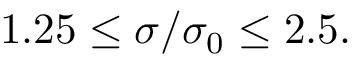<formula> <loc_0><loc_0><loc_500><loc_500>1 . 2 5 \leq \sigma / \sigma _ { 0 } \leq 2 . 5 .</formula> 